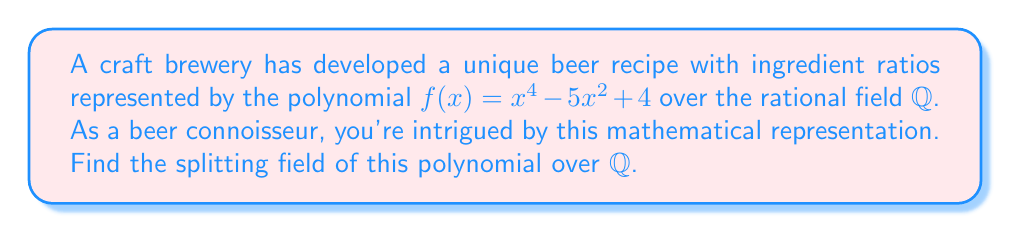Help me with this question. 1) First, let's factor the polynomial $f(x) = x^4 - 5x^2 + 4$:
   $f(x) = (x^2 - 1)(x^2 - 4) = (x+1)(x-1)(x+2)(x-2)$

2) The roots of $f(x)$ are $\pm 1$ and $\pm 2$. All of these roots are rational numbers.

3) The splitting field of a polynomial is the smallest field extension that contains all the roots of the polynomial.

4) Since all the roots are already in $\mathbb{Q}$, we don't need to extend the field.

5) Therefore, the splitting field of $f(x)$ over $\mathbb{Q}$ is $\mathbb{Q}$ itself.
Answer: $\mathbb{Q}$ 